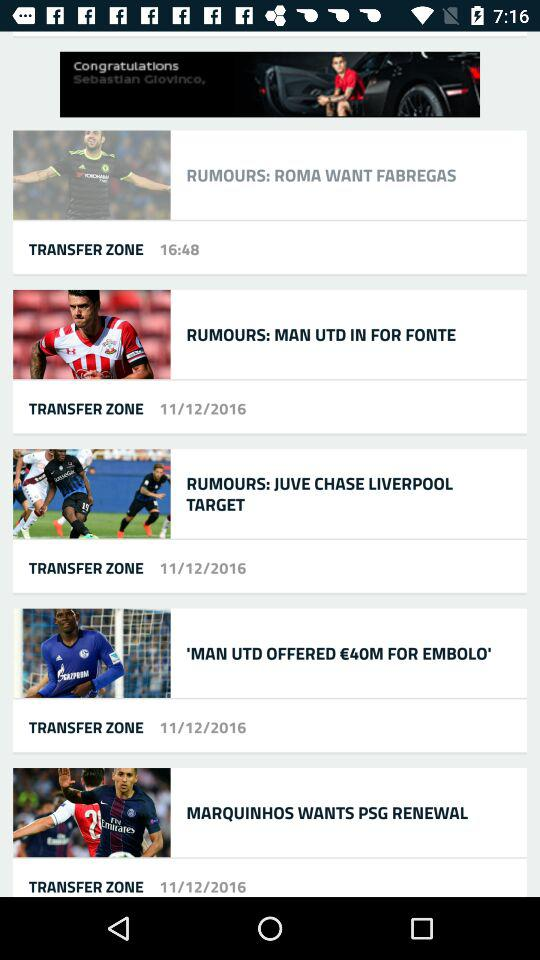What is the amount offered by Man Utd for Embolo? The amount offered by Man Utd for Embolo is €40 million. 